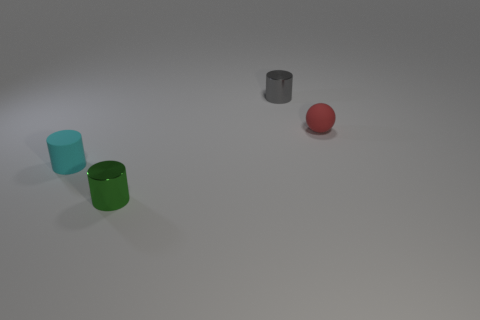Does the tiny cylinder that is behind the small red thing have the same material as the tiny green thing?
Ensure brevity in your answer.  Yes. Are there any matte things to the right of the small metal cylinder that is to the left of the small gray thing?
Your answer should be compact. Yes. What is the material of the tiny cyan object that is the same shape as the tiny green object?
Your answer should be compact. Rubber. Are there more tiny cylinders that are in front of the small red rubber ball than small gray cylinders that are behind the tiny gray metallic cylinder?
Provide a short and direct response. Yes. The tiny red thing that is the same material as the cyan object is what shape?
Provide a short and direct response. Sphere. Is the number of small shiny things in front of the small gray thing greater than the number of blue blocks?
Ensure brevity in your answer.  Yes. How many small rubber cylinders are the same color as the tiny matte sphere?
Provide a succinct answer. 0. Is the number of green cylinders greater than the number of large cyan balls?
Provide a succinct answer. Yes. What is the small cyan cylinder made of?
Offer a terse response. Rubber. There is a shiny cylinder behind the small cyan rubber object; what is its size?
Provide a short and direct response. Small. 